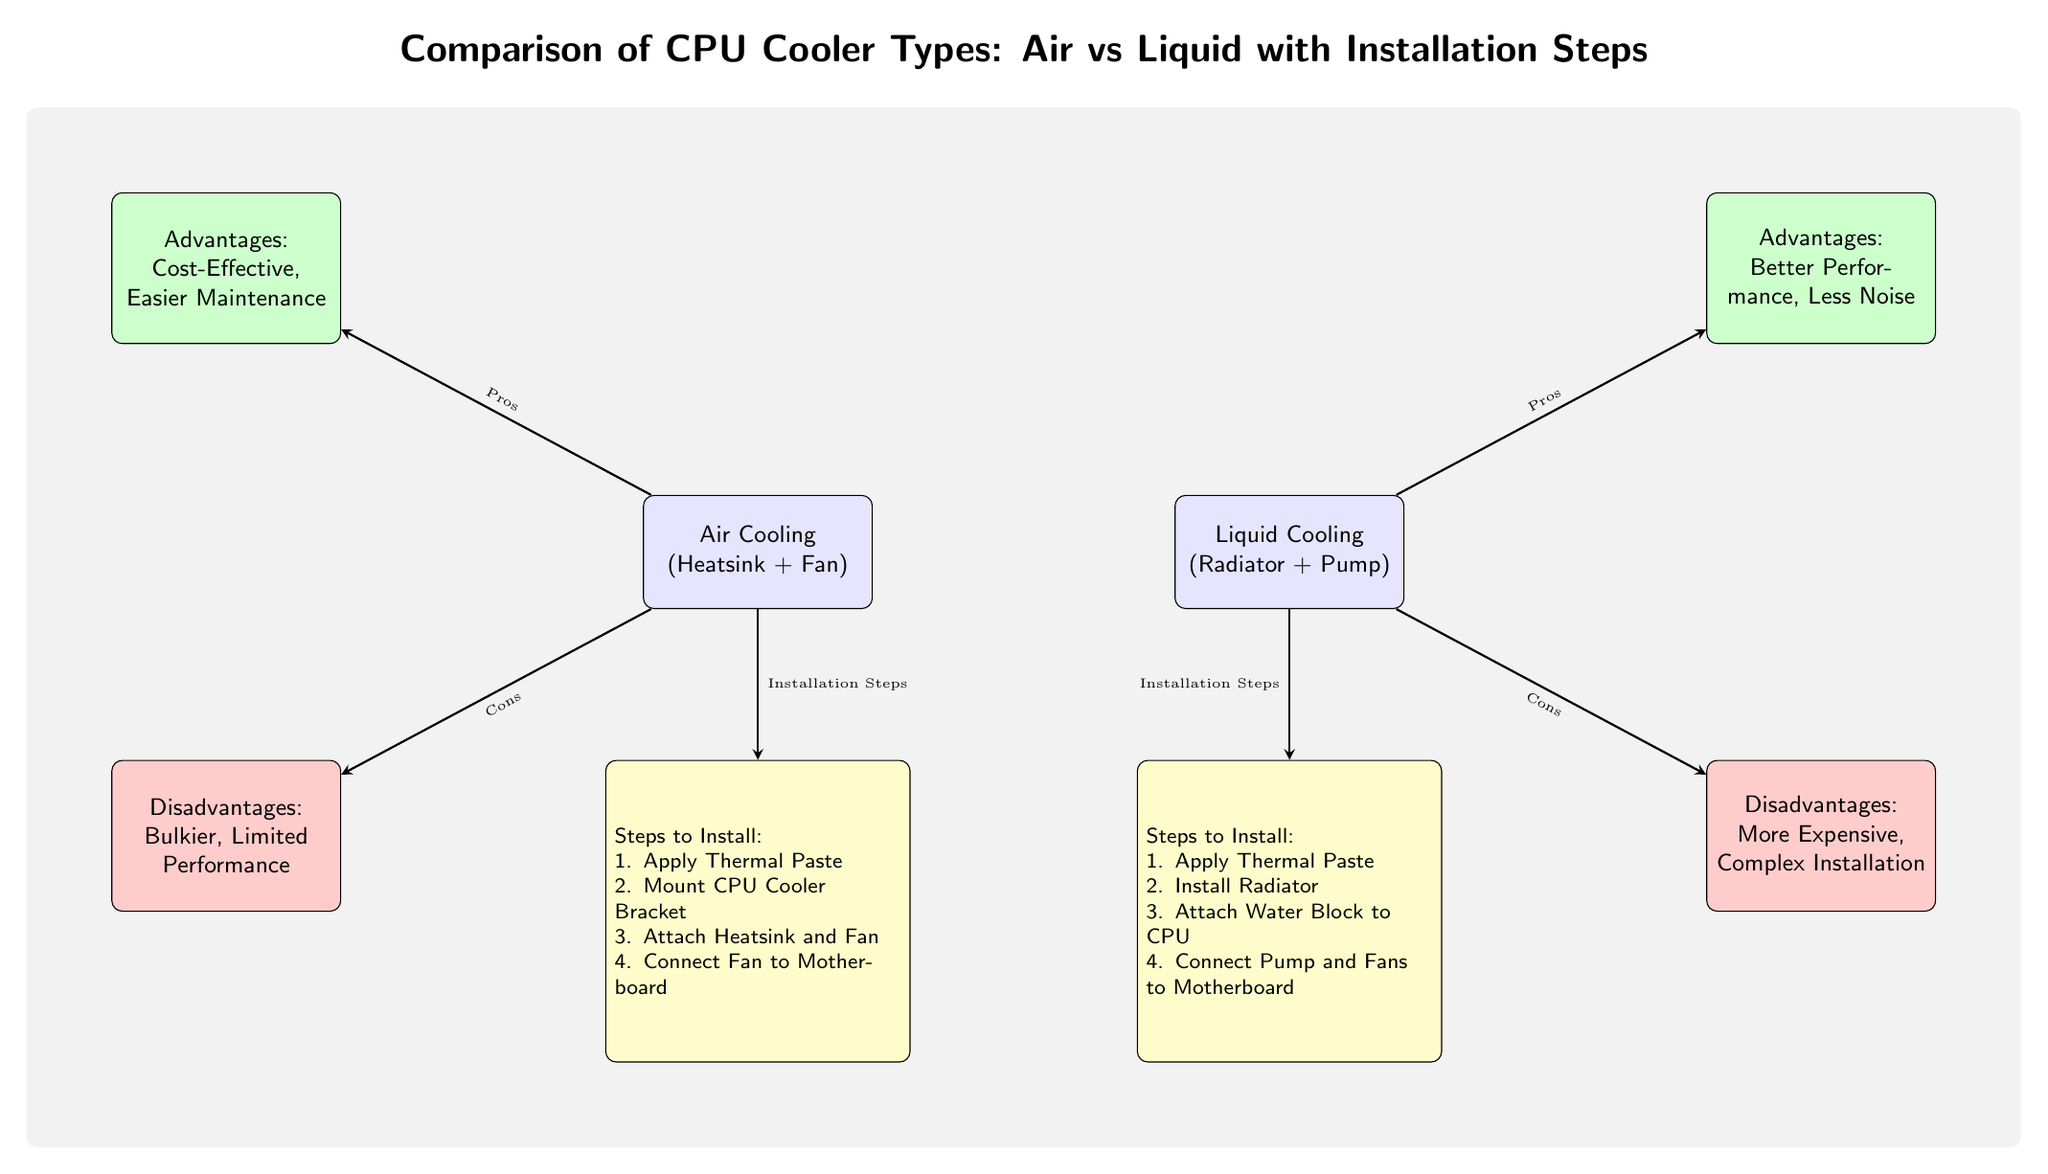What are the two types of CPU coolers compared in the diagram? The diagram explicitly lists "Air Cooling (Heatsink + Fan)" and "Liquid Cooling (Radiator + Pump)" as the two CPU cooler types being compared.
Answer: Air Cooling, Liquid Cooling How many advantages are listed for liquid cooling? There are two advantages listed for liquid cooling: "Better Performance" and "Less Noise." This is directly observable from the advantages section associated with liquid cooling.
Answer: 2 What is the first step for both air and liquid cooling installation? The first installation step for both air and liquid cooling is "Apply Thermal Paste," as stated in both steps sections for the respective coolers. This is a common initial step that helps in thermal conductivity.
Answer: Apply Thermal Paste Which cooler type has a disadvantage of being bulkier? The diagram indicates that "Air Cooling" has the disadvantage of being "Bulkier," as shown in the disadvantages section for air cooling.
Answer: Air Cooling What are the total steps outlined for installing air cooling? The total number of steps for air cooling installation is four, as explicitly listed in the steps section dedicated to air cooling. Each step is numbered (1-4), confirming the quantity.
Answer: 4 Which CPU cooler type is described as "More Expensive"? The "Liquid Cooling" type is described as "More Expensive" in its disadvantages section, indicating that it typically costs more than the air cooling option.
Answer: Liquid Cooling What are the disadvantages of air cooling? The diagram lists two disadvantages for air cooling, which are "Bulkier" and "Limited Performance," showing that while it has benefits, it also has drawbacks.
Answer: Bulkier, Limited Performance What step involves connecting parts to the motherboard? For air cooling, the fourth step is "Connect Fan to Motherboard," and for liquid cooling, the fourth step is "Connect Pump and Fans to Motherboard." Both involve connecting components to enable cooling functionality.
Answer: Connect Fan and Pump to Motherboard 